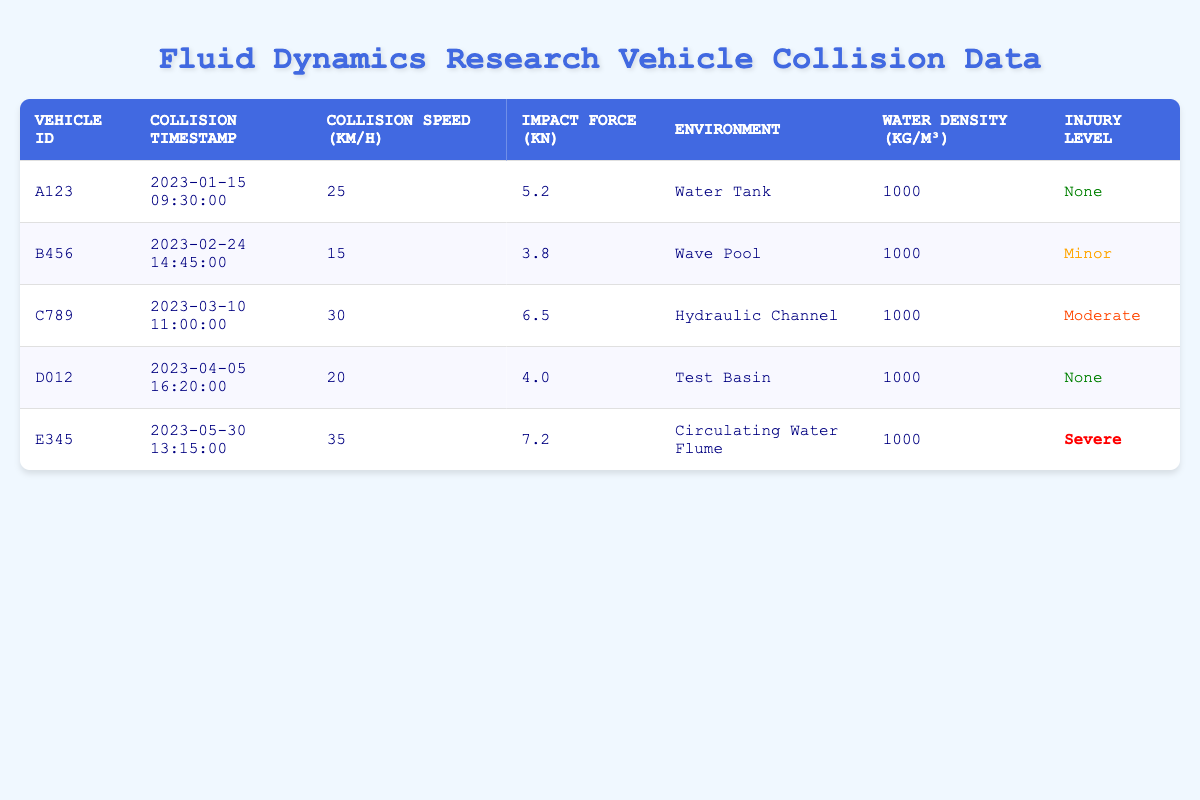What is the vehicle ID of the collision with the highest impact force? The collision with the highest impact force is associated with vehicle ID E345, which has an impact force of 7.2 kN.
Answer: E345 How many collisions resulted in severe injury? There is one collision with a severe injury level, which corresponds to vehicle E345.
Answer: 1 What was the average collision speed of all vehicles in the data? To find the average speed, add the speeds of all vehicles (25 + 15 + 30 + 20 + 35 = 125) and divide by the number of vehicles (5), which gives 125 / 5 = 25 km/h.
Answer: 25 km/h Did any collisions occur in a hydraulic channel? Yes, there is one collision that took place in a hydraulic channel, involving vehicle C789.
Answer: Yes What is the difference in collision speed between the highest and lowest speed recorded? The highest speed is 35 km/h (vehicle E345) and the lowest speed is 15 km/h (vehicle B456), so the difference is 35 - 15 = 20 km/h.
Answer: 20 km/h How many collisions occurred in a water tank environment? According to the data, there was one collision in a water tank environment, associated with vehicle A123.
Answer: 1 Is it true that all collisions occurred in environments with water density of 1000 kg/m³? Yes, all listed collisions occurred in environments with a water density of 1000 kg/m³.
Answer: Yes What is the total impact force recorded from all vehicles? To get the total impact force, add each vehicle's impact force: (5.2 + 3.8 + 6.5 + 4.0 + 7.2 = 26.7 kN).
Answer: 26.7 kN What injury level corresponds with the collision that occurred on 2023-02-24? The collision on 2023-02-24 involved vehicle B456 and resulted in a minor injury level.
Answer: Minor Which vehicle had a collision speed of 30 km/h and what was its injury level? Vehicle C789 had a collision speed of 30 km/h, and the injury level for this collision was moderate.
Answer: C789, Moderate 